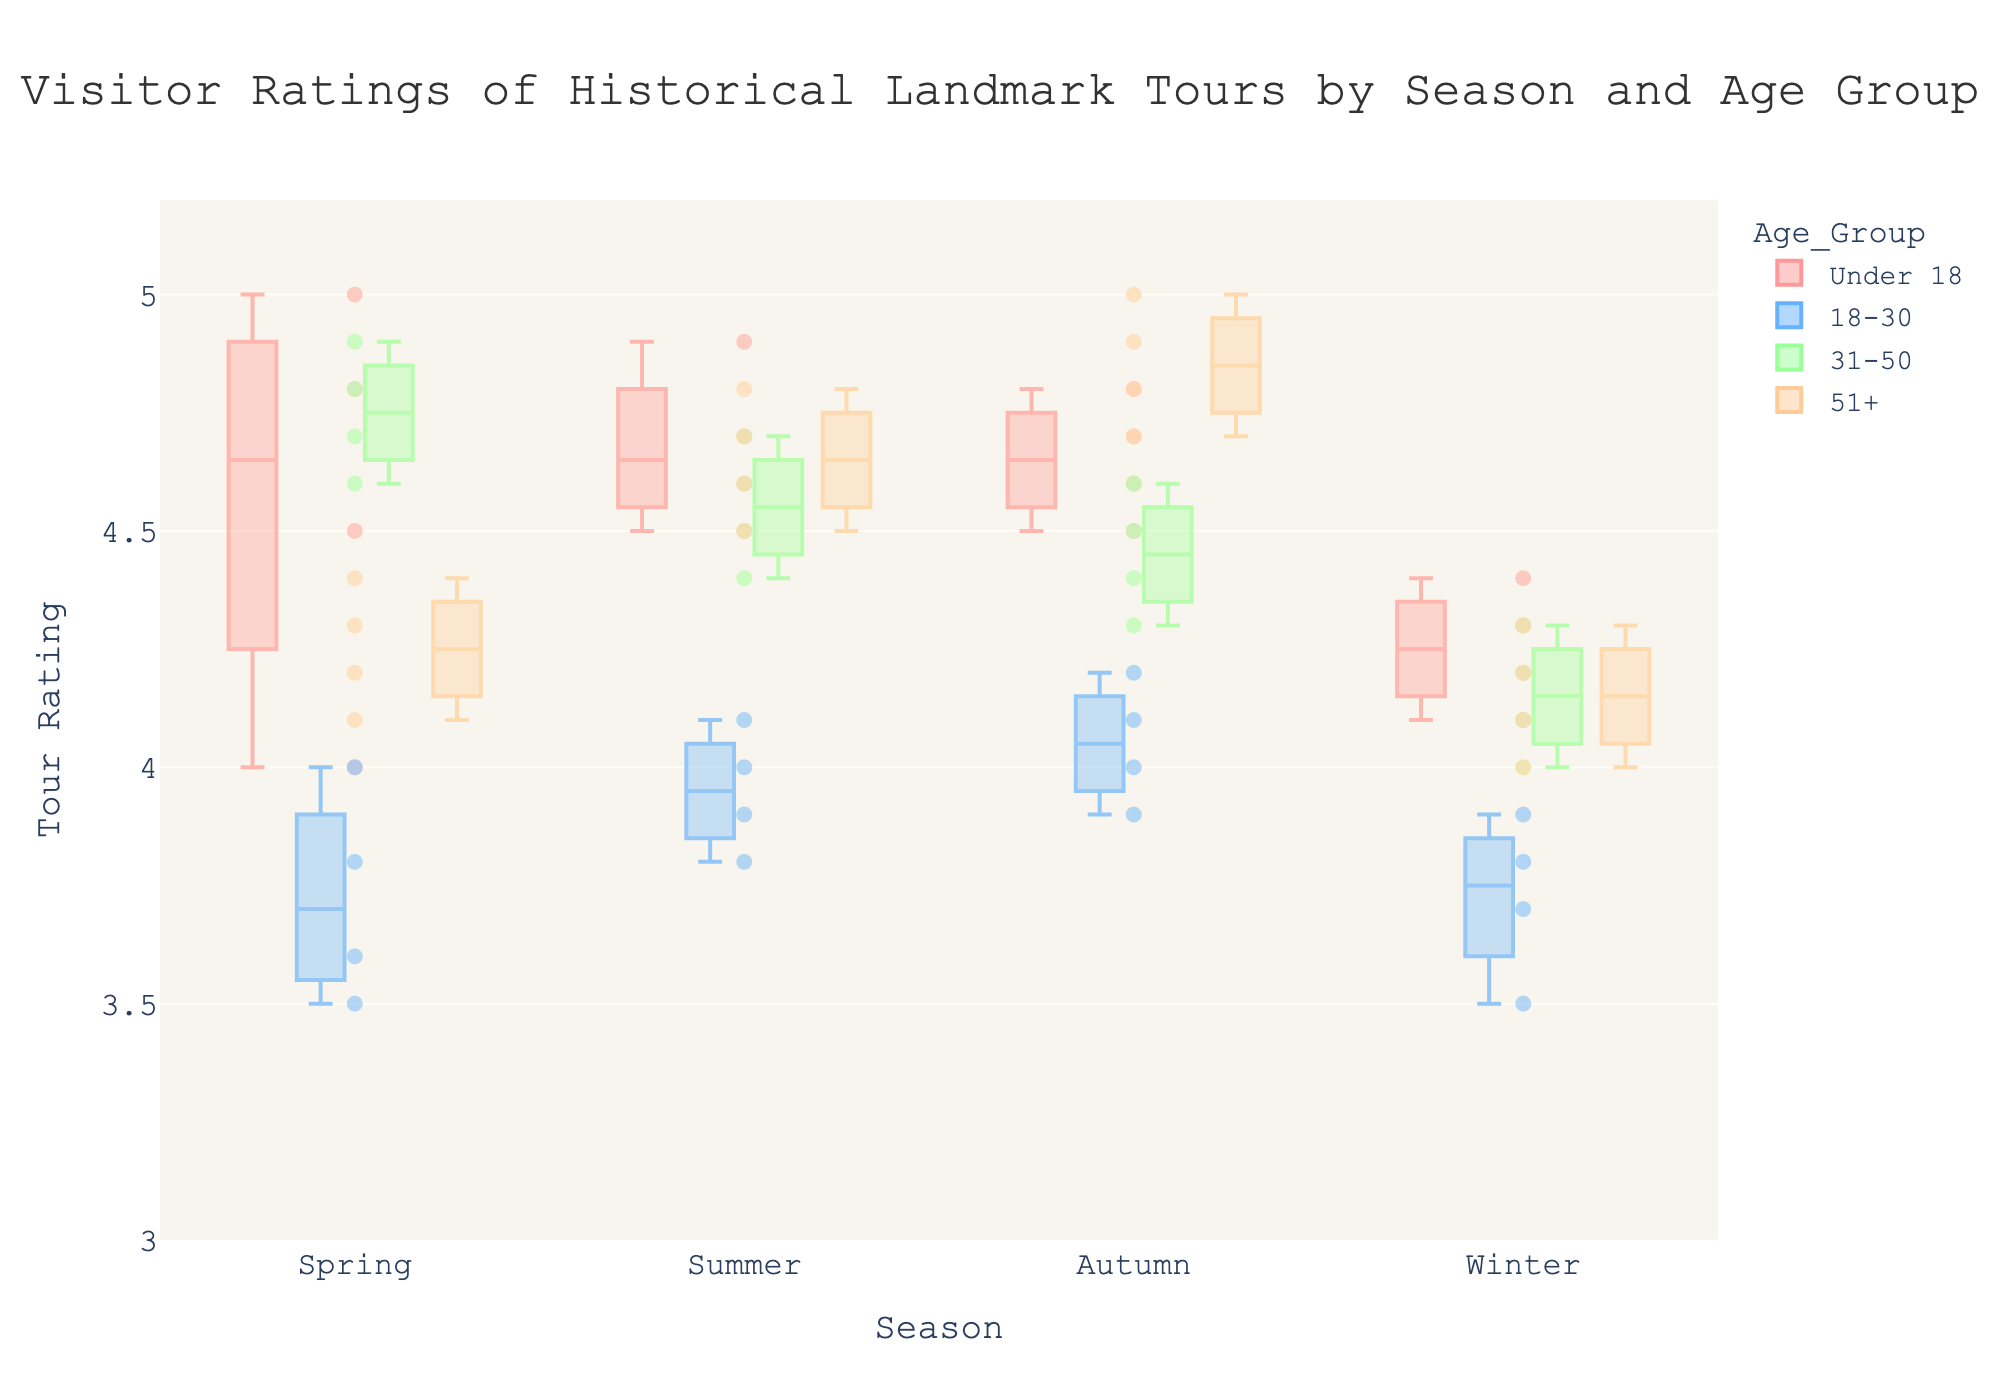What is the title of the figure? The title is usually located at the top of the chart. It provides an overview of what the figure is about.
Answer: Visitor Ratings of Historical Landmark Tours by Season and Age Group How many different age groups are displayed in the figure? The colors and labels in the legend show the different age groups. By counting the distinct groups in the legend, we can determine the number of age groups.
Answer: 4 Which season has the highest median rating for the "Under 18" age group? Look at the median line within the box for each season for the "Under 18" group. The highest median line corresponds to the season with the highest median rating.
Answer: Summer What is the range of ratings for the "31-50" age group in Winter? The range is determined by the distance between the whiskers of the box plot for the "31-50" age group in Winter.
Answer: 4.0 to 4.3 Compare the interquartile range (IQR) of the "51+" age group between Summer and Winter. Which season has a larger IQR? The IQR is the distance between the first quartile (bottom of the box) and the third quartile (top of the box). By visually comparing these distances, we determine which one is larger.
Answer: Winter How do the patterns of ratings in Autumn for "18-30" compare to those in Spring for the same age group? Compare the box plots and scatter points for the "18-30" group in Autumn and Spring. Look at the medians, spreads, and any outliers.
Answer: Autumn ratings tend to be higher and more concentrated around the median than Spring Which age group shows the most variation in ratings during Spring? The variation is represented by the length of the box and whiskers, along with the spread of scatter points. The group with the widest box and longest whiskers has the most variation.
Answer: 18-30 How do the median ratings for the "31-50" age group change across the seasons? Observe the median line within the box for the "31-50" age group across all seasons. Note the trend or change in its position.
Answer: Decreases from Spring to Winter Are there any outliers in the ratings for the "51+" age group, and if so, in which season? Outliers are scatter points that fall outside the whiskers of the box plot. Identify them for the "51+" age group.
Answer: No outliers Among all age groups, which season has the most consistent (least variation) ratings? The season with the shortest boxes and whiskers across all age groups indicates the least variation in ratings.
Answer: Winter 